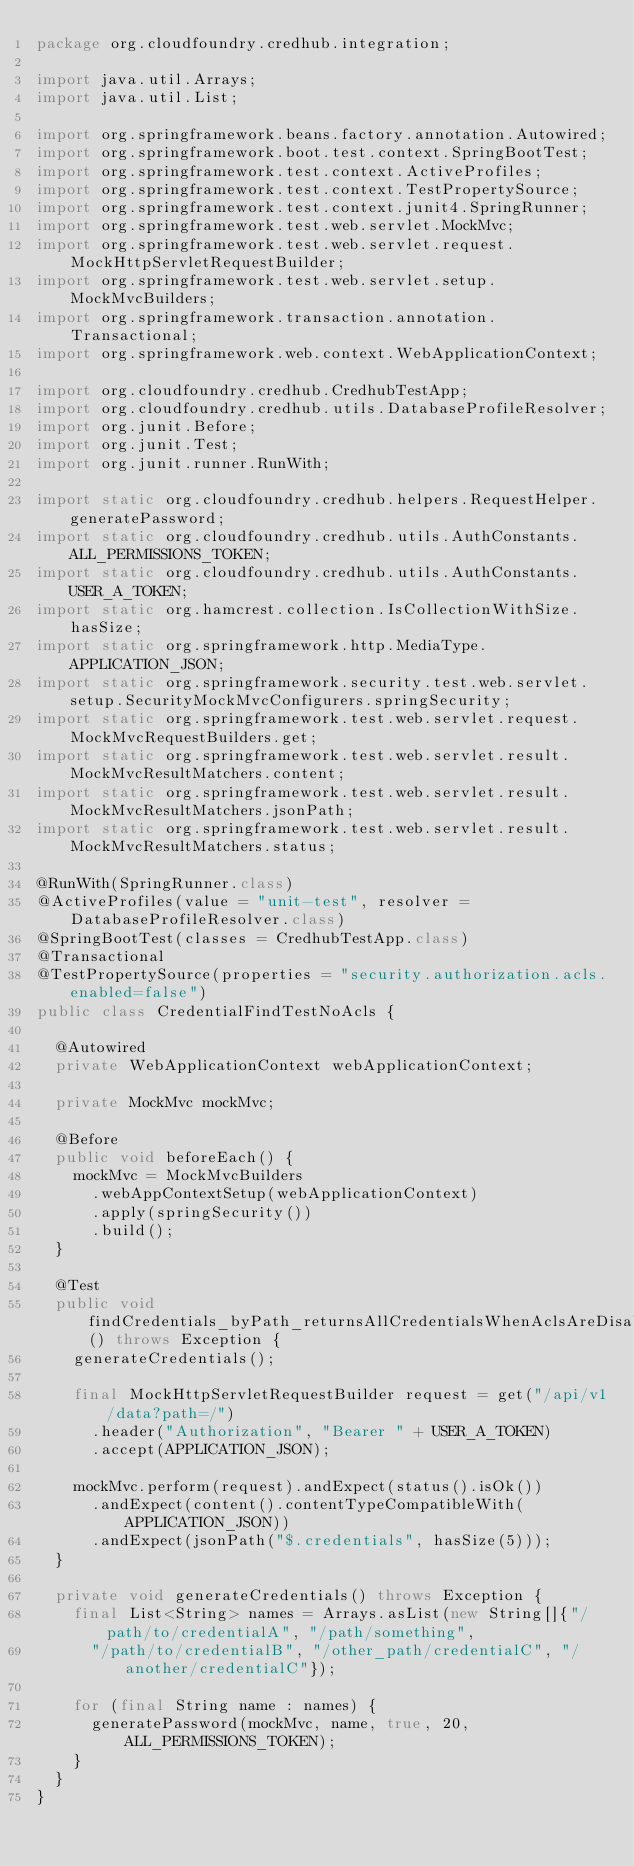<code> <loc_0><loc_0><loc_500><loc_500><_Java_>package org.cloudfoundry.credhub.integration;

import java.util.Arrays;
import java.util.List;

import org.springframework.beans.factory.annotation.Autowired;
import org.springframework.boot.test.context.SpringBootTest;
import org.springframework.test.context.ActiveProfiles;
import org.springframework.test.context.TestPropertySource;
import org.springframework.test.context.junit4.SpringRunner;
import org.springframework.test.web.servlet.MockMvc;
import org.springframework.test.web.servlet.request.MockHttpServletRequestBuilder;
import org.springframework.test.web.servlet.setup.MockMvcBuilders;
import org.springframework.transaction.annotation.Transactional;
import org.springframework.web.context.WebApplicationContext;

import org.cloudfoundry.credhub.CredhubTestApp;
import org.cloudfoundry.credhub.utils.DatabaseProfileResolver;
import org.junit.Before;
import org.junit.Test;
import org.junit.runner.RunWith;

import static org.cloudfoundry.credhub.helpers.RequestHelper.generatePassword;
import static org.cloudfoundry.credhub.utils.AuthConstants.ALL_PERMISSIONS_TOKEN;
import static org.cloudfoundry.credhub.utils.AuthConstants.USER_A_TOKEN;
import static org.hamcrest.collection.IsCollectionWithSize.hasSize;
import static org.springframework.http.MediaType.APPLICATION_JSON;
import static org.springframework.security.test.web.servlet.setup.SecurityMockMvcConfigurers.springSecurity;
import static org.springframework.test.web.servlet.request.MockMvcRequestBuilders.get;
import static org.springframework.test.web.servlet.result.MockMvcResultMatchers.content;
import static org.springframework.test.web.servlet.result.MockMvcResultMatchers.jsonPath;
import static org.springframework.test.web.servlet.result.MockMvcResultMatchers.status;

@RunWith(SpringRunner.class)
@ActiveProfiles(value = "unit-test", resolver = DatabaseProfileResolver.class)
@SpringBootTest(classes = CredhubTestApp.class)
@Transactional
@TestPropertySource(properties = "security.authorization.acls.enabled=false")
public class CredentialFindTestNoAcls {

  @Autowired
  private WebApplicationContext webApplicationContext;

  private MockMvc mockMvc;

  @Before
  public void beforeEach() {
    mockMvc = MockMvcBuilders
      .webAppContextSetup(webApplicationContext)
      .apply(springSecurity())
      .build();
  }

  @Test
  public void findCredentials_byPath_returnsAllCredentialsWhenAclsAreDisabled() throws Exception {
    generateCredentials();

    final MockHttpServletRequestBuilder request = get("/api/v1/data?path=/")
      .header("Authorization", "Bearer " + USER_A_TOKEN)
      .accept(APPLICATION_JSON);

    mockMvc.perform(request).andExpect(status().isOk())
      .andExpect(content().contentTypeCompatibleWith(APPLICATION_JSON))
      .andExpect(jsonPath("$.credentials", hasSize(5)));
  }

  private void generateCredentials() throws Exception {
    final List<String> names = Arrays.asList(new String[]{"/path/to/credentialA", "/path/something",
      "/path/to/credentialB", "/other_path/credentialC", "/another/credentialC"});

    for (final String name : names) {
      generatePassword(mockMvc, name, true, 20, ALL_PERMISSIONS_TOKEN);
    }
  }
}
</code> 